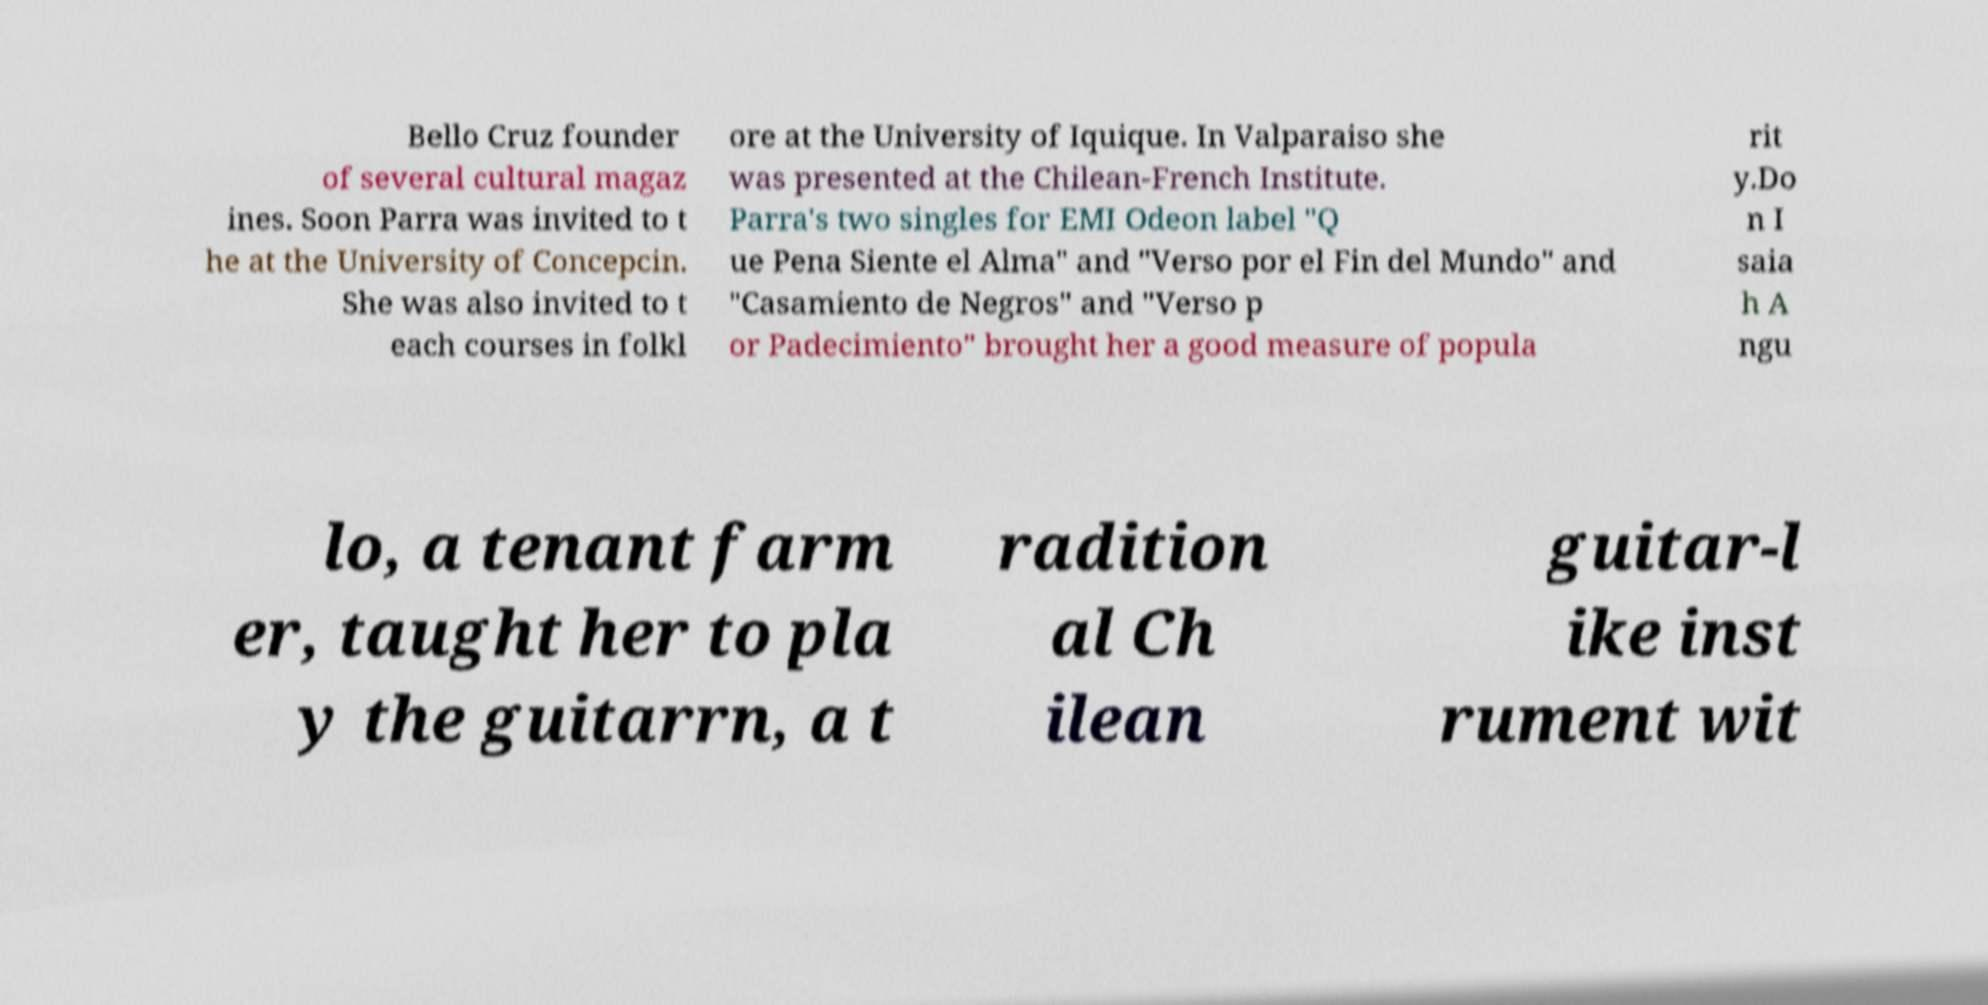Please identify and transcribe the text found in this image. Bello Cruz founder of several cultural magaz ines. Soon Parra was invited to t he at the University of Concepcin. She was also invited to t each courses in folkl ore at the University of Iquique. In Valparaiso she was presented at the Chilean-French Institute. Parra's two singles for EMI Odeon label "Q ue Pena Siente el Alma" and "Verso por el Fin del Mundo" and "Casamiento de Negros" and "Verso p or Padecimiento" brought her a good measure of popula rit y.Do n I saia h A ngu lo, a tenant farm er, taught her to pla y the guitarrn, a t radition al Ch ilean guitar-l ike inst rument wit 